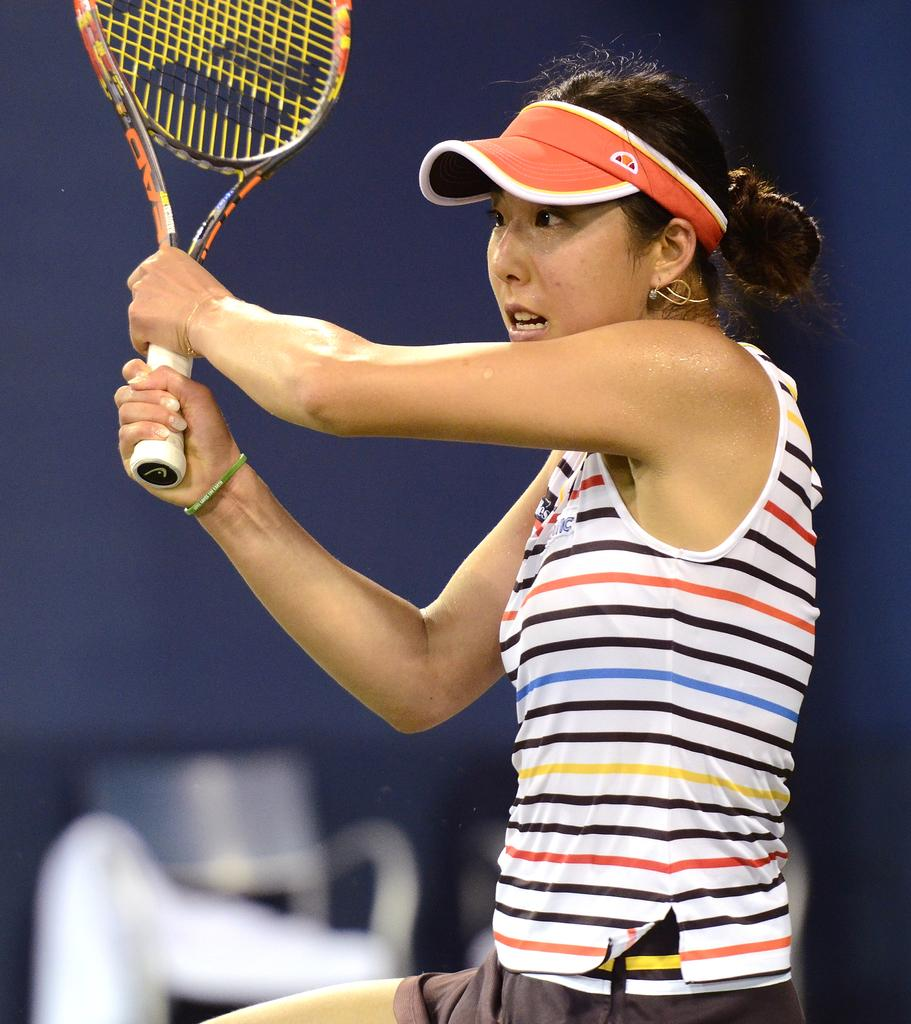What is the person in the image doing? The person is standing in the image. What object is the person holding in the image? The person is holding a racket. What type of clothing is the person wearing on their head? The person is wearing an orange cap. Where is the scarecrow located in the image? There is no scarecrow present in the image. Is the person holding a key in the image? There is no key visible in the image. 